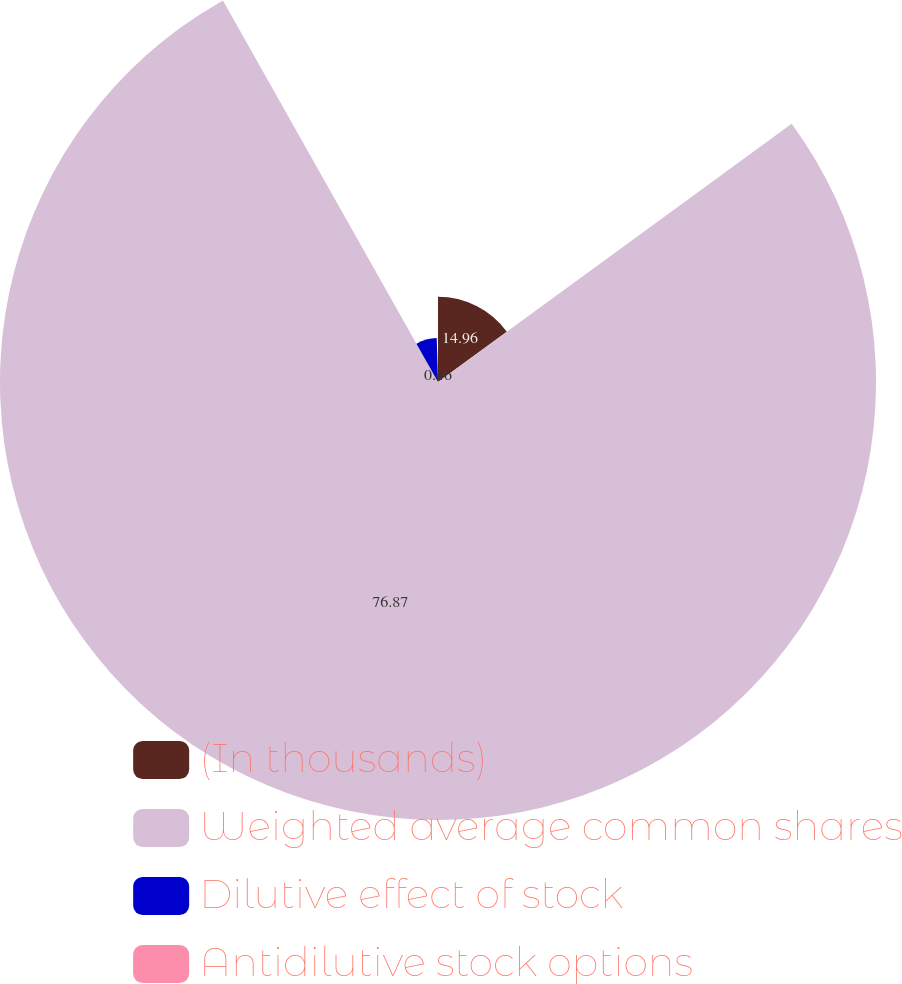<chart> <loc_0><loc_0><loc_500><loc_500><pie_chart><fcel>(In thousands)<fcel>Weighted average common shares<fcel>Dilutive effect of stock<fcel>Antidilutive stock options<nl><fcel>14.96%<fcel>76.88%<fcel>7.71%<fcel>0.46%<nl></chart> 